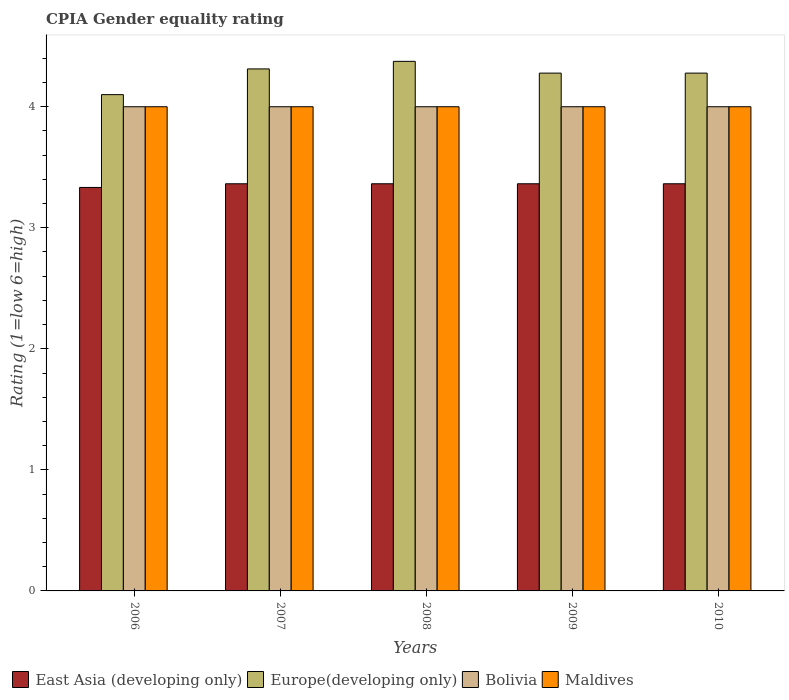How many different coloured bars are there?
Give a very brief answer. 4. Are the number of bars on each tick of the X-axis equal?
Your answer should be compact. Yes. What is the label of the 3rd group of bars from the left?
Give a very brief answer. 2008. What is the CPIA rating in Maldives in 2008?
Your answer should be very brief. 4. Across all years, what is the maximum CPIA rating in Maldives?
Your response must be concise. 4. Across all years, what is the minimum CPIA rating in Bolivia?
Offer a very short reply. 4. In which year was the CPIA rating in East Asia (developing only) minimum?
Your answer should be compact. 2006. What is the total CPIA rating in Bolivia in the graph?
Ensure brevity in your answer.  20. What is the difference between the CPIA rating in Europe(developing only) in 2009 and the CPIA rating in Maldives in 2006?
Provide a succinct answer. 0.28. In the year 2010, what is the difference between the CPIA rating in Europe(developing only) and CPIA rating in Bolivia?
Provide a succinct answer. 0.28. Is the difference between the CPIA rating in Europe(developing only) in 2007 and 2008 greater than the difference between the CPIA rating in Bolivia in 2007 and 2008?
Ensure brevity in your answer.  No. What is the difference between the highest and the second highest CPIA rating in Europe(developing only)?
Give a very brief answer. 0.06. Is the sum of the CPIA rating in Europe(developing only) in 2006 and 2010 greater than the maximum CPIA rating in Maldives across all years?
Your answer should be very brief. Yes. What does the 1st bar from the left in 2006 represents?
Offer a very short reply. East Asia (developing only). What does the 1st bar from the right in 2008 represents?
Provide a short and direct response. Maldives. Is it the case that in every year, the sum of the CPIA rating in Europe(developing only) and CPIA rating in Bolivia is greater than the CPIA rating in Maldives?
Offer a terse response. Yes. What is the difference between two consecutive major ticks on the Y-axis?
Offer a terse response. 1. Are the values on the major ticks of Y-axis written in scientific E-notation?
Provide a succinct answer. No. Where does the legend appear in the graph?
Your answer should be compact. Bottom left. How are the legend labels stacked?
Provide a short and direct response. Horizontal. What is the title of the graph?
Give a very brief answer. CPIA Gender equality rating. What is the label or title of the X-axis?
Your answer should be compact. Years. What is the Rating (1=low 6=high) of East Asia (developing only) in 2006?
Your response must be concise. 3.33. What is the Rating (1=low 6=high) in East Asia (developing only) in 2007?
Ensure brevity in your answer.  3.36. What is the Rating (1=low 6=high) in Europe(developing only) in 2007?
Make the answer very short. 4.31. What is the Rating (1=low 6=high) of East Asia (developing only) in 2008?
Ensure brevity in your answer.  3.36. What is the Rating (1=low 6=high) of Europe(developing only) in 2008?
Make the answer very short. 4.38. What is the Rating (1=low 6=high) in Bolivia in 2008?
Offer a terse response. 4. What is the Rating (1=low 6=high) of East Asia (developing only) in 2009?
Ensure brevity in your answer.  3.36. What is the Rating (1=low 6=high) of Europe(developing only) in 2009?
Give a very brief answer. 4.28. What is the Rating (1=low 6=high) in Maldives in 2009?
Make the answer very short. 4. What is the Rating (1=low 6=high) of East Asia (developing only) in 2010?
Your answer should be very brief. 3.36. What is the Rating (1=low 6=high) in Europe(developing only) in 2010?
Offer a very short reply. 4.28. What is the Rating (1=low 6=high) in Bolivia in 2010?
Your answer should be compact. 4. What is the Rating (1=low 6=high) of Maldives in 2010?
Offer a terse response. 4. Across all years, what is the maximum Rating (1=low 6=high) in East Asia (developing only)?
Make the answer very short. 3.36. Across all years, what is the maximum Rating (1=low 6=high) of Europe(developing only)?
Provide a succinct answer. 4.38. Across all years, what is the maximum Rating (1=low 6=high) of Bolivia?
Give a very brief answer. 4. Across all years, what is the maximum Rating (1=low 6=high) in Maldives?
Your answer should be compact. 4. Across all years, what is the minimum Rating (1=low 6=high) of East Asia (developing only)?
Your response must be concise. 3.33. Across all years, what is the minimum Rating (1=low 6=high) of Europe(developing only)?
Offer a very short reply. 4.1. What is the total Rating (1=low 6=high) in East Asia (developing only) in the graph?
Make the answer very short. 16.79. What is the total Rating (1=low 6=high) of Europe(developing only) in the graph?
Give a very brief answer. 21.34. What is the difference between the Rating (1=low 6=high) of East Asia (developing only) in 2006 and that in 2007?
Make the answer very short. -0.03. What is the difference between the Rating (1=low 6=high) in Europe(developing only) in 2006 and that in 2007?
Keep it short and to the point. -0.21. What is the difference between the Rating (1=low 6=high) in East Asia (developing only) in 2006 and that in 2008?
Make the answer very short. -0.03. What is the difference between the Rating (1=low 6=high) of Europe(developing only) in 2006 and that in 2008?
Keep it short and to the point. -0.28. What is the difference between the Rating (1=low 6=high) in Bolivia in 2006 and that in 2008?
Make the answer very short. 0. What is the difference between the Rating (1=low 6=high) of East Asia (developing only) in 2006 and that in 2009?
Your response must be concise. -0.03. What is the difference between the Rating (1=low 6=high) of Europe(developing only) in 2006 and that in 2009?
Give a very brief answer. -0.18. What is the difference between the Rating (1=low 6=high) of East Asia (developing only) in 2006 and that in 2010?
Ensure brevity in your answer.  -0.03. What is the difference between the Rating (1=low 6=high) of Europe(developing only) in 2006 and that in 2010?
Keep it short and to the point. -0.18. What is the difference between the Rating (1=low 6=high) of Bolivia in 2006 and that in 2010?
Your response must be concise. 0. What is the difference between the Rating (1=low 6=high) of Europe(developing only) in 2007 and that in 2008?
Ensure brevity in your answer.  -0.06. What is the difference between the Rating (1=low 6=high) of Europe(developing only) in 2007 and that in 2009?
Provide a succinct answer. 0.03. What is the difference between the Rating (1=low 6=high) in Maldives in 2007 and that in 2009?
Your answer should be compact. 0. What is the difference between the Rating (1=low 6=high) of East Asia (developing only) in 2007 and that in 2010?
Offer a terse response. 0. What is the difference between the Rating (1=low 6=high) of Europe(developing only) in 2007 and that in 2010?
Your answer should be compact. 0.03. What is the difference between the Rating (1=low 6=high) of Bolivia in 2007 and that in 2010?
Provide a succinct answer. 0. What is the difference between the Rating (1=low 6=high) in Maldives in 2007 and that in 2010?
Ensure brevity in your answer.  0. What is the difference between the Rating (1=low 6=high) of Europe(developing only) in 2008 and that in 2009?
Your answer should be compact. 0.1. What is the difference between the Rating (1=low 6=high) of Europe(developing only) in 2008 and that in 2010?
Your answer should be compact. 0.1. What is the difference between the Rating (1=low 6=high) in Maldives in 2008 and that in 2010?
Keep it short and to the point. 0. What is the difference between the Rating (1=low 6=high) of East Asia (developing only) in 2009 and that in 2010?
Your answer should be very brief. 0. What is the difference between the Rating (1=low 6=high) of Bolivia in 2009 and that in 2010?
Provide a succinct answer. 0. What is the difference between the Rating (1=low 6=high) in Maldives in 2009 and that in 2010?
Ensure brevity in your answer.  0. What is the difference between the Rating (1=low 6=high) in East Asia (developing only) in 2006 and the Rating (1=low 6=high) in Europe(developing only) in 2007?
Your answer should be compact. -0.98. What is the difference between the Rating (1=low 6=high) in East Asia (developing only) in 2006 and the Rating (1=low 6=high) in Bolivia in 2007?
Keep it short and to the point. -0.67. What is the difference between the Rating (1=low 6=high) of Europe(developing only) in 2006 and the Rating (1=low 6=high) of Bolivia in 2007?
Ensure brevity in your answer.  0.1. What is the difference between the Rating (1=low 6=high) in Europe(developing only) in 2006 and the Rating (1=low 6=high) in Maldives in 2007?
Your answer should be very brief. 0.1. What is the difference between the Rating (1=low 6=high) in Bolivia in 2006 and the Rating (1=low 6=high) in Maldives in 2007?
Offer a terse response. 0. What is the difference between the Rating (1=low 6=high) in East Asia (developing only) in 2006 and the Rating (1=low 6=high) in Europe(developing only) in 2008?
Ensure brevity in your answer.  -1.04. What is the difference between the Rating (1=low 6=high) in East Asia (developing only) in 2006 and the Rating (1=low 6=high) in Maldives in 2008?
Make the answer very short. -0.67. What is the difference between the Rating (1=low 6=high) of East Asia (developing only) in 2006 and the Rating (1=low 6=high) of Europe(developing only) in 2009?
Offer a very short reply. -0.94. What is the difference between the Rating (1=low 6=high) in East Asia (developing only) in 2006 and the Rating (1=low 6=high) in Bolivia in 2009?
Your response must be concise. -0.67. What is the difference between the Rating (1=low 6=high) in Bolivia in 2006 and the Rating (1=low 6=high) in Maldives in 2009?
Keep it short and to the point. 0. What is the difference between the Rating (1=low 6=high) in East Asia (developing only) in 2006 and the Rating (1=low 6=high) in Europe(developing only) in 2010?
Provide a short and direct response. -0.94. What is the difference between the Rating (1=low 6=high) of East Asia (developing only) in 2006 and the Rating (1=low 6=high) of Bolivia in 2010?
Offer a terse response. -0.67. What is the difference between the Rating (1=low 6=high) in Europe(developing only) in 2006 and the Rating (1=low 6=high) in Bolivia in 2010?
Offer a very short reply. 0.1. What is the difference between the Rating (1=low 6=high) in Europe(developing only) in 2006 and the Rating (1=low 6=high) in Maldives in 2010?
Your answer should be very brief. 0.1. What is the difference between the Rating (1=low 6=high) in East Asia (developing only) in 2007 and the Rating (1=low 6=high) in Europe(developing only) in 2008?
Your answer should be compact. -1.01. What is the difference between the Rating (1=low 6=high) of East Asia (developing only) in 2007 and the Rating (1=low 6=high) of Bolivia in 2008?
Your answer should be very brief. -0.64. What is the difference between the Rating (1=low 6=high) in East Asia (developing only) in 2007 and the Rating (1=low 6=high) in Maldives in 2008?
Offer a very short reply. -0.64. What is the difference between the Rating (1=low 6=high) in Europe(developing only) in 2007 and the Rating (1=low 6=high) in Bolivia in 2008?
Offer a terse response. 0.31. What is the difference between the Rating (1=low 6=high) in Europe(developing only) in 2007 and the Rating (1=low 6=high) in Maldives in 2008?
Give a very brief answer. 0.31. What is the difference between the Rating (1=low 6=high) in East Asia (developing only) in 2007 and the Rating (1=low 6=high) in Europe(developing only) in 2009?
Offer a very short reply. -0.91. What is the difference between the Rating (1=low 6=high) of East Asia (developing only) in 2007 and the Rating (1=low 6=high) of Bolivia in 2009?
Keep it short and to the point. -0.64. What is the difference between the Rating (1=low 6=high) of East Asia (developing only) in 2007 and the Rating (1=low 6=high) of Maldives in 2009?
Give a very brief answer. -0.64. What is the difference between the Rating (1=low 6=high) in Europe(developing only) in 2007 and the Rating (1=low 6=high) in Bolivia in 2009?
Offer a terse response. 0.31. What is the difference between the Rating (1=low 6=high) of Europe(developing only) in 2007 and the Rating (1=low 6=high) of Maldives in 2009?
Keep it short and to the point. 0.31. What is the difference between the Rating (1=low 6=high) of Bolivia in 2007 and the Rating (1=low 6=high) of Maldives in 2009?
Your response must be concise. 0. What is the difference between the Rating (1=low 6=high) in East Asia (developing only) in 2007 and the Rating (1=low 6=high) in Europe(developing only) in 2010?
Offer a terse response. -0.91. What is the difference between the Rating (1=low 6=high) in East Asia (developing only) in 2007 and the Rating (1=low 6=high) in Bolivia in 2010?
Your answer should be very brief. -0.64. What is the difference between the Rating (1=low 6=high) in East Asia (developing only) in 2007 and the Rating (1=low 6=high) in Maldives in 2010?
Make the answer very short. -0.64. What is the difference between the Rating (1=low 6=high) of Europe(developing only) in 2007 and the Rating (1=low 6=high) of Bolivia in 2010?
Give a very brief answer. 0.31. What is the difference between the Rating (1=low 6=high) of Europe(developing only) in 2007 and the Rating (1=low 6=high) of Maldives in 2010?
Ensure brevity in your answer.  0.31. What is the difference between the Rating (1=low 6=high) of Bolivia in 2007 and the Rating (1=low 6=high) of Maldives in 2010?
Your answer should be very brief. 0. What is the difference between the Rating (1=low 6=high) in East Asia (developing only) in 2008 and the Rating (1=low 6=high) in Europe(developing only) in 2009?
Your answer should be very brief. -0.91. What is the difference between the Rating (1=low 6=high) in East Asia (developing only) in 2008 and the Rating (1=low 6=high) in Bolivia in 2009?
Give a very brief answer. -0.64. What is the difference between the Rating (1=low 6=high) in East Asia (developing only) in 2008 and the Rating (1=low 6=high) in Maldives in 2009?
Keep it short and to the point. -0.64. What is the difference between the Rating (1=low 6=high) of Europe(developing only) in 2008 and the Rating (1=low 6=high) of Maldives in 2009?
Your answer should be very brief. 0.38. What is the difference between the Rating (1=low 6=high) in Bolivia in 2008 and the Rating (1=low 6=high) in Maldives in 2009?
Offer a terse response. 0. What is the difference between the Rating (1=low 6=high) of East Asia (developing only) in 2008 and the Rating (1=low 6=high) of Europe(developing only) in 2010?
Your answer should be very brief. -0.91. What is the difference between the Rating (1=low 6=high) of East Asia (developing only) in 2008 and the Rating (1=low 6=high) of Bolivia in 2010?
Your answer should be very brief. -0.64. What is the difference between the Rating (1=low 6=high) of East Asia (developing only) in 2008 and the Rating (1=low 6=high) of Maldives in 2010?
Your response must be concise. -0.64. What is the difference between the Rating (1=low 6=high) of Europe(developing only) in 2008 and the Rating (1=low 6=high) of Bolivia in 2010?
Keep it short and to the point. 0.38. What is the difference between the Rating (1=low 6=high) in Europe(developing only) in 2008 and the Rating (1=low 6=high) in Maldives in 2010?
Your answer should be compact. 0.38. What is the difference between the Rating (1=low 6=high) in Bolivia in 2008 and the Rating (1=low 6=high) in Maldives in 2010?
Your answer should be very brief. 0. What is the difference between the Rating (1=low 6=high) of East Asia (developing only) in 2009 and the Rating (1=low 6=high) of Europe(developing only) in 2010?
Your answer should be very brief. -0.91. What is the difference between the Rating (1=low 6=high) in East Asia (developing only) in 2009 and the Rating (1=low 6=high) in Bolivia in 2010?
Your response must be concise. -0.64. What is the difference between the Rating (1=low 6=high) of East Asia (developing only) in 2009 and the Rating (1=low 6=high) of Maldives in 2010?
Give a very brief answer. -0.64. What is the difference between the Rating (1=low 6=high) in Europe(developing only) in 2009 and the Rating (1=low 6=high) in Bolivia in 2010?
Offer a terse response. 0.28. What is the difference between the Rating (1=low 6=high) in Europe(developing only) in 2009 and the Rating (1=low 6=high) in Maldives in 2010?
Give a very brief answer. 0.28. What is the average Rating (1=low 6=high) in East Asia (developing only) per year?
Offer a very short reply. 3.36. What is the average Rating (1=low 6=high) in Europe(developing only) per year?
Offer a terse response. 4.27. What is the average Rating (1=low 6=high) of Bolivia per year?
Ensure brevity in your answer.  4. In the year 2006, what is the difference between the Rating (1=low 6=high) in East Asia (developing only) and Rating (1=low 6=high) in Europe(developing only)?
Provide a short and direct response. -0.77. In the year 2006, what is the difference between the Rating (1=low 6=high) in East Asia (developing only) and Rating (1=low 6=high) in Bolivia?
Give a very brief answer. -0.67. In the year 2006, what is the difference between the Rating (1=low 6=high) of Europe(developing only) and Rating (1=low 6=high) of Bolivia?
Offer a very short reply. 0.1. In the year 2006, what is the difference between the Rating (1=low 6=high) of Europe(developing only) and Rating (1=low 6=high) of Maldives?
Provide a succinct answer. 0.1. In the year 2007, what is the difference between the Rating (1=low 6=high) of East Asia (developing only) and Rating (1=low 6=high) of Europe(developing only)?
Your answer should be very brief. -0.95. In the year 2007, what is the difference between the Rating (1=low 6=high) of East Asia (developing only) and Rating (1=low 6=high) of Bolivia?
Your answer should be very brief. -0.64. In the year 2007, what is the difference between the Rating (1=low 6=high) of East Asia (developing only) and Rating (1=low 6=high) of Maldives?
Your answer should be compact. -0.64. In the year 2007, what is the difference between the Rating (1=low 6=high) in Europe(developing only) and Rating (1=low 6=high) in Bolivia?
Your response must be concise. 0.31. In the year 2007, what is the difference between the Rating (1=low 6=high) in Europe(developing only) and Rating (1=low 6=high) in Maldives?
Your answer should be very brief. 0.31. In the year 2007, what is the difference between the Rating (1=low 6=high) of Bolivia and Rating (1=low 6=high) of Maldives?
Make the answer very short. 0. In the year 2008, what is the difference between the Rating (1=low 6=high) of East Asia (developing only) and Rating (1=low 6=high) of Europe(developing only)?
Keep it short and to the point. -1.01. In the year 2008, what is the difference between the Rating (1=low 6=high) of East Asia (developing only) and Rating (1=low 6=high) of Bolivia?
Your response must be concise. -0.64. In the year 2008, what is the difference between the Rating (1=low 6=high) of East Asia (developing only) and Rating (1=low 6=high) of Maldives?
Offer a very short reply. -0.64. In the year 2008, what is the difference between the Rating (1=low 6=high) of Europe(developing only) and Rating (1=low 6=high) of Maldives?
Offer a terse response. 0.38. In the year 2009, what is the difference between the Rating (1=low 6=high) in East Asia (developing only) and Rating (1=low 6=high) in Europe(developing only)?
Your answer should be very brief. -0.91. In the year 2009, what is the difference between the Rating (1=low 6=high) in East Asia (developing only) and Rating (1=low 6=high) in Bolivia?
Ensure brevity in your answer.  -0.64. In the year 2009, what is the difference between the Rating (1=low 6=high) of East Asia (developing only) and Rating (1=low 6=high) of Maldives?
Ensure brevity in your answer.  -0.64. In the year 2009, what is the difference between the Rating (1=low 6=high) in Europe(developing only) and Rating (1=low 6=high) in Bolivia?
Offer a terse response. 0.28. In the year 2009, what is the difference between the Rating (1=low 6=high) in Europe(developing only) and Rating (1=low 6=high) in Maldives?
Your response must be concise. 0.28. In the year 2010, what is the difference between the Rating (1=low 6=high) in East Asia (developing only) and Rating (1=low 6=high) in Europe(developing only)?
Ensure brevity in your answer.  -0.91. In the year 2010, what is the difference between the Rating (1=low 6=high) in East Asia (developing only) and Rating (1=low 6=high) in Bolivia?
Give a very brief answer. -0.64. In the year 2010, what is the difference between the Rating (1=low 6=high) of East Asia (developing only) and Rating (1=low 6=high) of Maldives?
Your answer should be very brief. -0.64. In the year 2010, what is the difference between the Rating (1=low 6=high) in Europe(developing only) and Rating (1=low 6=high) in Bolivia?
Your answer should be very brief. 0.28. In the year 2010, what is the difference between the Rating (1=low 6=high) of Europe(developing only) and Rating (1=low 6=high) of Maldives?
Make the answer very short. 0.28. In the year 2010, what is the difference between the Rating (1=low 6=high) in Bolivia and Rating (1=low 6=high) in Maldives?
Your response must be concise. 0. What is the ratio of the Rating (1=low 6=high) in Europe(developing only) in 2006 to that in 2007?
Offer a very short reply. 0.95. What is the ratio of the Rating (1=low 6=high) of Bolivia in 2006 to that in 2007?
Give a very brief answer. 1. What is the ratio of the Rating (1=low 6=high) in Europe(developing only) in 2006 to that in 2008?
Offer a terse response. 0.94. What is the ratio of the Rating (1=low 6=high) of Bolivia in 2006 to that in 2008?
Make the answer very short. 1. What is the ratio of the Rating (1=low 6=high) of East Asia (developing only) in 2006 to that in 2009?
Your answer should be compact. 0.99. What is the ratio of the Rating (1=low 6=high) of Europe(developing only) in 2006 to that in 2009?
Your response must be concise. 0.96. What is the ratio of the Rating (1=low 6=high) in Maldives in 2006 to that in 2009?
Offer a terse response. 1. What is the ratio of the Rating (1=low 6=high) of East Asia (developing only) in 2006 to that in 2010?
Provide a succinct answer. 0.99. What is the ratio of the Rating (1=low 6=high) in Europe(developing only) in 2006 to that in 2010?
Provide a short and direct response. 0.96. What is the ratio of the Rating (1=low 6=high) in Maldives in 2006 to that in 2010?
Provide a succinct answer. 1. What is the ratio of the Rating (1=low 6=high) of East Asia (developing only) in 2007 to that in 2008?
Offer a very short reply. 1. What is the ratio of the Rating (1=low 6=high) of Europe(developing only) in 2007 to that in 2008?
Your answer should be very brief. 0.99. What is the ratio of the Rating (1=low 6=high) in Bolivia in 2007 to that in 2008?
Your response must be concise. 1. What is the ratio of the Rating (1=low 6=high) in Maldives in 2007 to that in 2008?
Your response must be concise. 1. What is the ratio of the Rating (1=low 6=high) in Europe(developing only) in 2007 to that in 2009?
Your answer should be compact. 1.01. What is the ratio of the Rating (1=low 6=high) of Bolivia in 2007 to that in 2009?
Provide a succinct answer. 1. What is the ratio of the Rating (1=low 6=high) in East Asia (developing only) in 2007 to that in 2010?
Offer a very short reply. 1. What is the ratio of the Rating (1=low 6=high) of Bolivia in 2007 to that in 2010?
Offer a terse response. 1. What is the ratio of the Rating (1=low 6=high) of Maldives in 2007 to that in 2010?
Offer a very short reply. 1. What is the ratio of the Rating (1=low 6=high) of East Asia (developing only) in 2008 to that in 2009?
Provide a short and direct response. 1. What is the ratio of the Rating (1=low 6=high) of Europe(developing only) in 2008 to that in 2009?
Provide a succinct answer. 1.02. What is the ratio of the Rating (1=low 6=high) in East Asia (developing only) in 2008 to that in 2010?
Offer a terse response. 1. What is the ratio of the Rating (1=low 6=high) in Europe(developing only) in 2008 to that in 2010?
Keep it short and to the point. 1.02. What is the ratio of the Rating (1=low 6=high) in Europe(developing only) in 2009 to that in 2010?
Your answer should be compact. 1. What is the ratio of the Rating (1=low 6=high) in Bolivia in 2009 to that in 2010?
Offer a very short reply. 1. What is the ratio of the Rating (1=low 6=high) in Maldives in 2009 to that in 2010?
Give a very brief answer. 1. What is the difference between the highest and the second highest Rating (1=low 6=high) in East Asia (developing only)?
Provide a short and direct response. 0. What is the difference between the highest and the second highest Rating (1=low 6=high) of Europe(developing only)?
Make the answer very short. 0.06. What is the difference between the highest and the second highest Rating (1=low 6=high) in Bolivia?
Provide a short and direct response. 0. What is the difference between the highest and the second highest Rating (1=low 6=high) in Maldives?
Your answer should be compact. 0. What is the difference between the highest and the lowest Rating (1=low 6=high) of East Asia (developing only)?
Make the answer very short. 0.03. What is the difference between the highest and the lowest Rating (1=low 6=high) of Europe(developing only)?
Your answer should be compact. 0.28. 